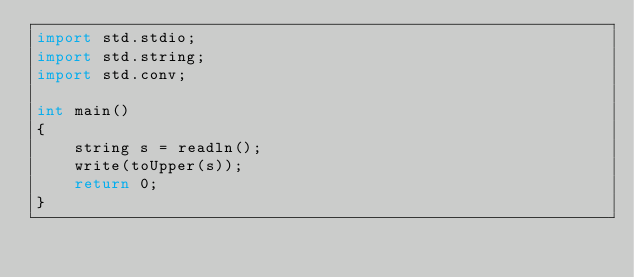<code> <loc_0><loc_0><loc_500><loc_500><_D_>import std.stdio;
import std.string;
import std.conv;

int main()
{
	string s = readln();
	write(toUpper(s));
	return 0;
}</code> 